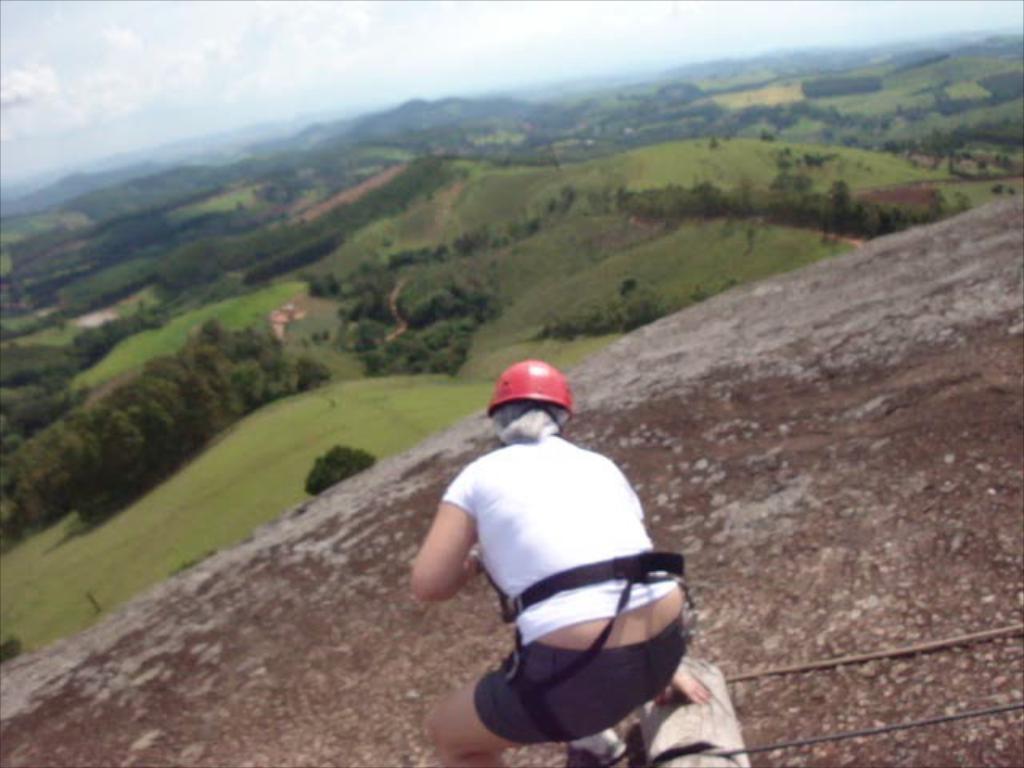Please provide a concise description of this image. There is a person wearing helmet is on a rock. There are tapes. In the background there are hills, trees and sky with clouds. 